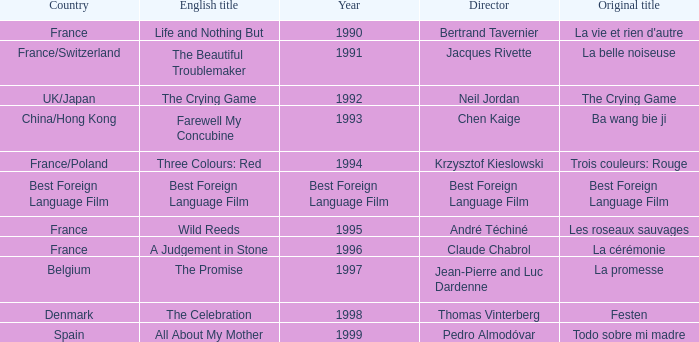Which Year has the Orginal title of La Cérémonie? 1996.0. 